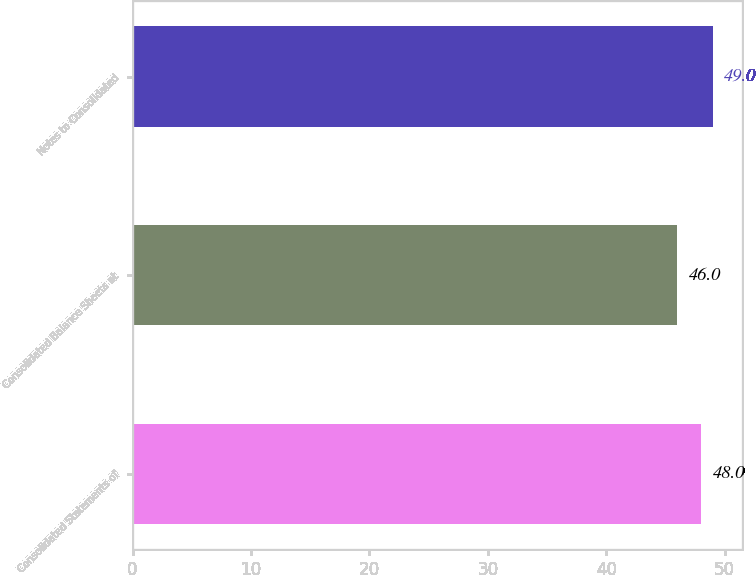Convert chart. <chart><loc_0><loc_0><loc_500><loc_500><bar_chart><fcel>Consolidated Statements of<fcel>Consolidated Balance Sheets at<fcel>Notes to Consolidated<nl><fcel>48<fcel>46<fcel>49<nl></chart> 